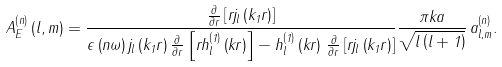Convert formula to latex. <formula><loc_0><loc_0><loc_500><loc_500>A ^ { \left ( n \right ) } _ { E } \left ( l , m \right ) = \frac { \frac { \partial } { \partial r } \left [ r j _ { l } \left ( k _ { 1 } r \right ) \right ] } { \epsilon \left ( n \omega \right ) j _ { l } \left ( k _ { 1 } r \right ) \frac { \partial } { \partial r } \left [ r h _ { l } ^ { \left ( 1 \right ) } \left ( k r \right ) \right ] - h _ { l } ^ { \left ( 1 \right ) } \left ( k r \right ) \, \frac { \partial } { \partial r } \left [ r j _ { l } \left ( k _ { 1 } r \right ) \right ] } \frac { \pi k a } { \sqrt { l \left ( l + 1 \right ) } } \, a _ { l , m } ^ { \left ( n \right ) } .</formula> 